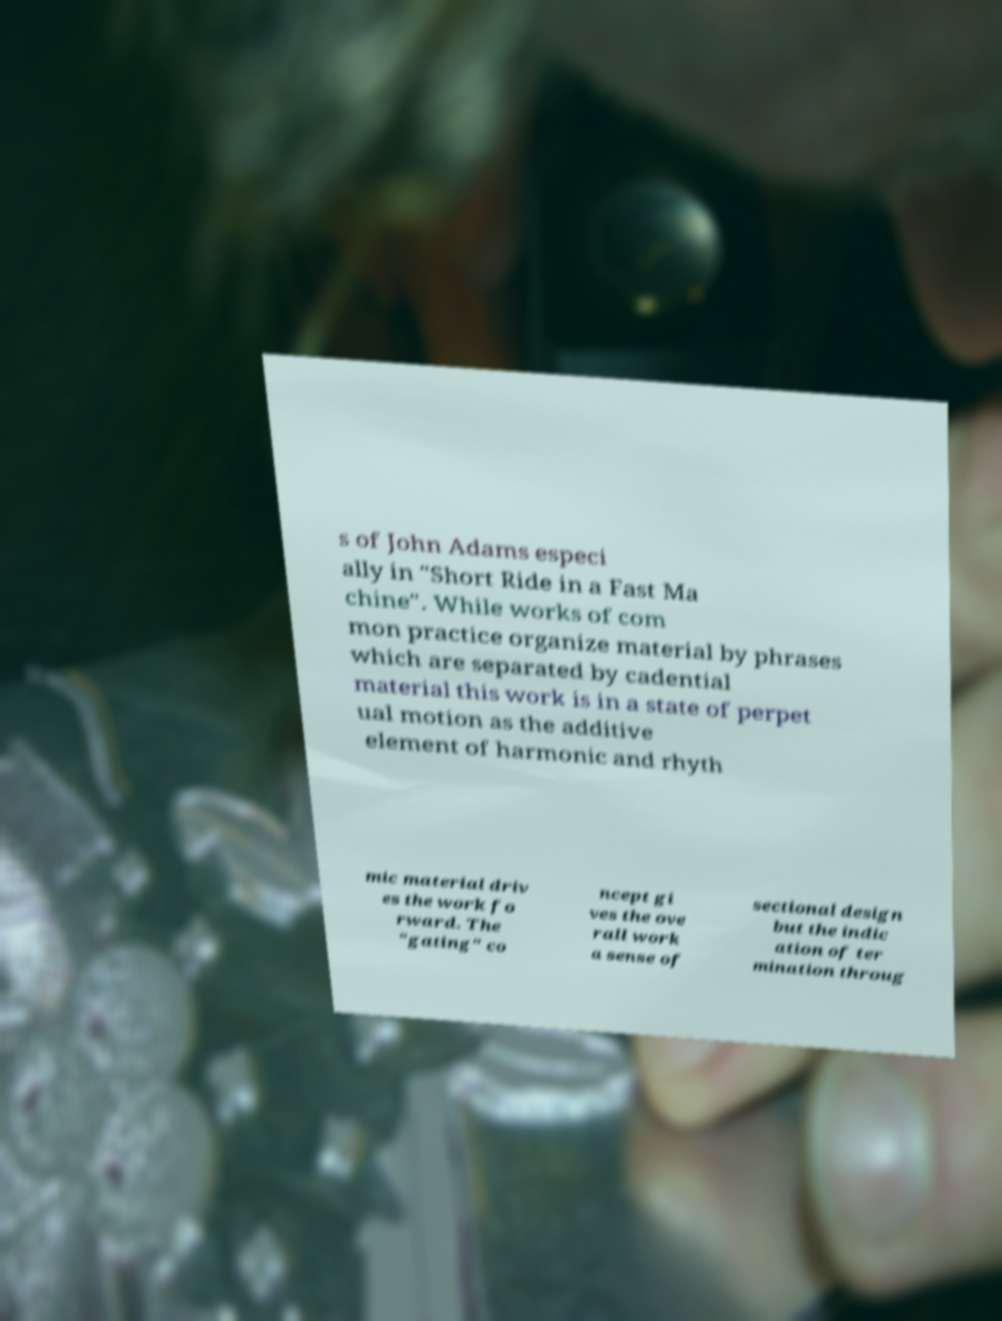I need the written content from this picture converted into text. Can you do that? s of John Adams especi ally in "Short Ride in a Fast Ma chine". While works of com mon practice organize material by phrases which are separated by cadential material this work is in a state of perpet ual motion as the additive element of harmonic and rhyth mic material driv es the work fo rward. The "gating" co ncept gi ves the ove rall work a sense of sectional design but the indic ation of ter mination throug 